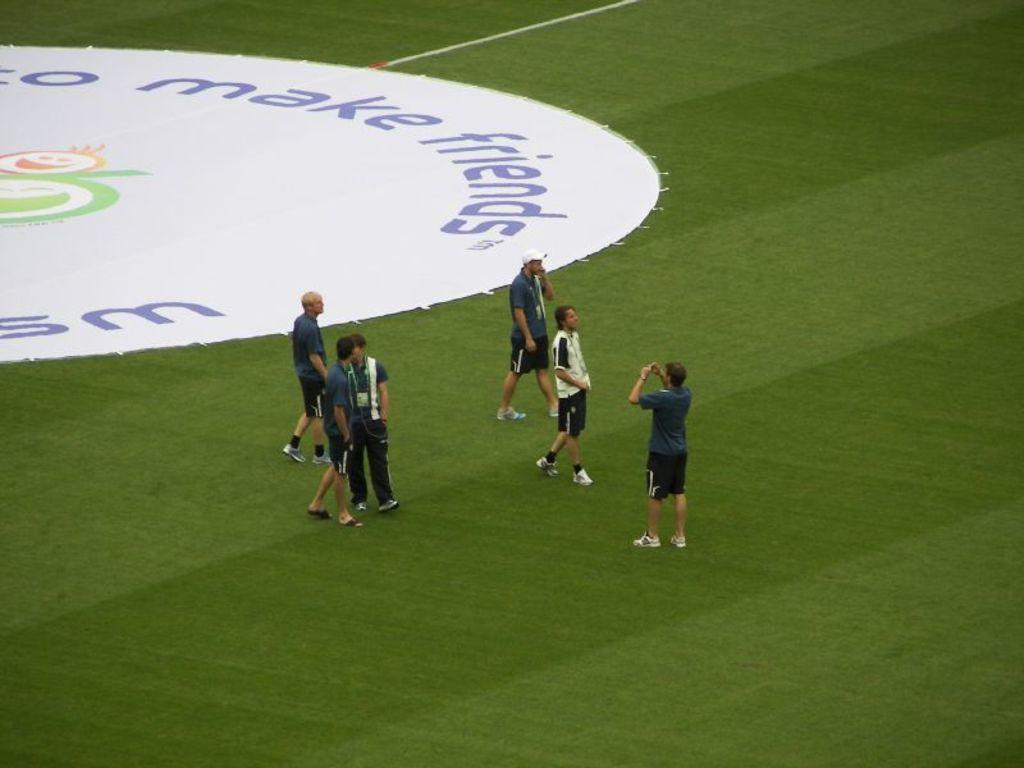Provide a one-sentence caption for the provided image. The stadium with players promoting Make Friends campaign. 